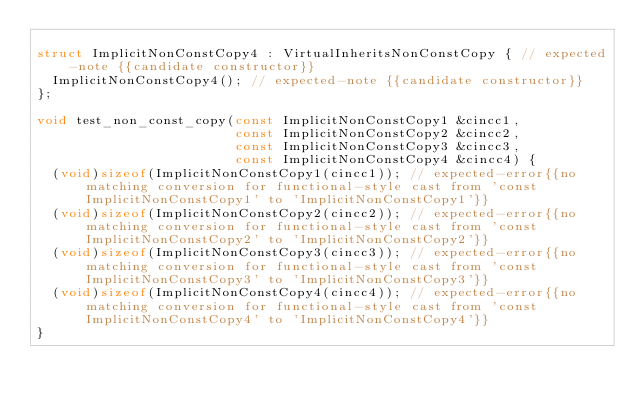Convert code to text. <code><loc_0><loc_0><loc_500><loc_500><_C++_>
struct ImplicitNonConstCopy4 : VirtualInheritsNonConstCopy { // expected-note {{candidate constructor}}
  ImplicitNonConstCopy4(); // expected-note {{candidate constructor}}
};

void test_non_const_copy(const ImplicitNonConstCopy1 &cincc1,
                         const ImplicitNonConstCopy2 &cincc2,
                         const ImplicitNonConstCopy3 &cincc3,
                         const ImplicitNonConstCopy4 &cincc4) {
  (void)sizeof(ImplicitNonConstCopy1(cincc1)); // expected-error{{no matching conversion for functional-style cast from 'const ImplicitNonConstCopy1' to 'ImplicitNonConstCopy1'}}
  (void)sizeof(ImplicitNonConstCopy2(cincc2)); // expected-error{{no matching conversion for functional-style cast from 'const ImplicitNonConstCopy2' to 'ImplicitNonConstCopy2'}}
  (void)sizeof(ImplicitNonConstCopy3(cincc3)); // expected-error{{no matching conversion for functional-style cast from 'const ImplicitNonConstCopy3' to 'ImplicitNonConstCopy3'}}
  (void)sizeof(ImplicitNonConstCopy4(cincc4)); // expected-error{{no matching conversion for functional-style cast from 'const ImplicitNonConstCopy4' to 'ImplicitNonConstCopy4'}}
}
</code> 